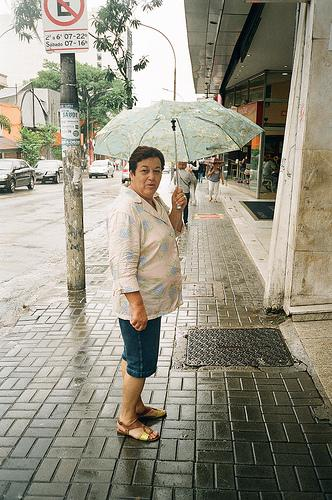Provide a brief overview of the main scene captured in the photograph. A lady holding a colorful umbrella is walking on a brick-patterned sidewalk in the rain along with other people. State the main subject in the image and their role. A woman with an umbrella acts as a pedestrian on a crowded sidewalk. Share a concise description of the central character and their surroundings in the image. A woman with a vibrant umbrella stands amidst a bustling street scene with wet sidewalks and parked cars. In a short statement, describe the core element of the image and their function. A woman manages to stay dry using a visually striking umbrella in a damp, bustling street scene. Summarize the primary subject and their activity in one sentence. A lady protects herself from the rain with a blue, gold-patterned umbrella on a busy sidewalk. Quickly mention the primary individual in the photo and explain their actions. A lady is walking outside holding an umbrella to protect herself from the rain. In a short sentence, describe the main person and their action in the image. A woman with an umbrella is strolling on a busy, wet sidewalk. Offer a brief commentary on the focal point of the image. A woman holding a stunning umbrella stands out among other pedestrians on a wet sidewalk. Mention the primary object of focus in the picture and their activity. A woman is holding a blue umbrella with a light blue and gold pattern, protecting herself from rain. Concisely describe the most prominent object and its purpose in the picture. A woman carries a decorative umbrella to shield herself from the rain. 